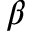Convert formula to latex. <formula><loc_0><loc_0><loc_500><loc_500>\beta</formula> 